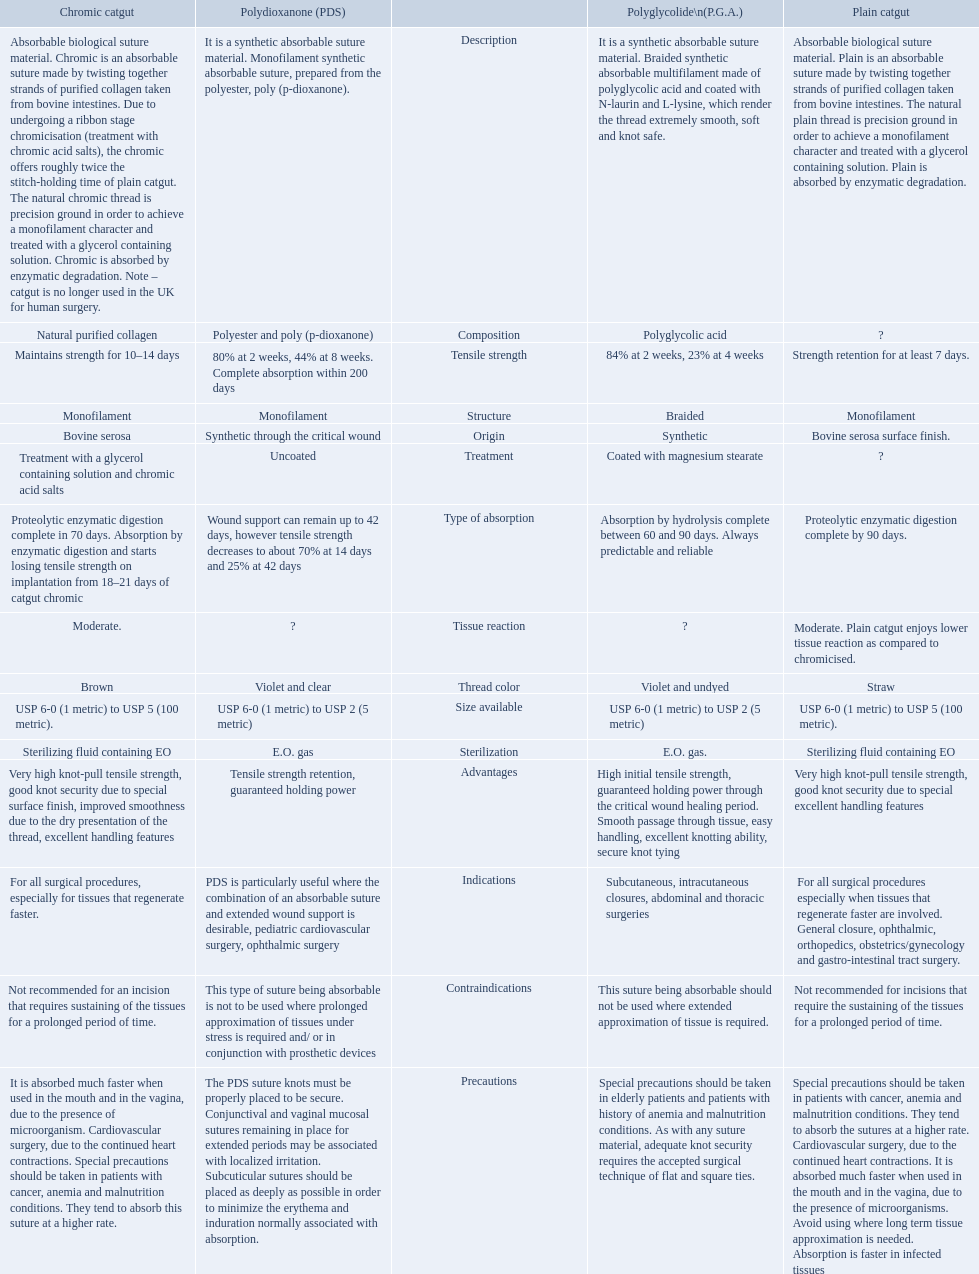What categories are listed in the suture materials comparison chart? Description, Composition, Tensile strength, Structure, Origin, Treatment, Type of absorption, Tissue reaction, Thread color, Size available, Sterilization, Advantages, Indications, Contraindications, Precautions. Of the testile strength, which is the lowest? Strength retention for at least 7 days. 